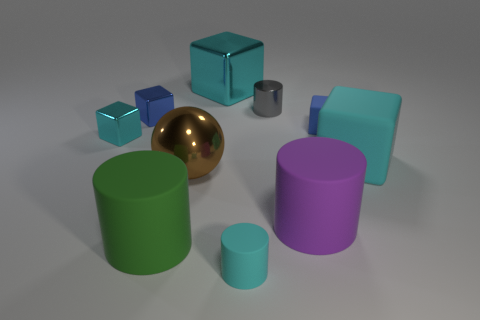Subtract all yellow cylinders. How many cyan cubes are left? 3 Subtract 2 blocks. How many blocks are left? 3 Subtract all big cyan shiny blocks. How many blocks are left? 4 Subtract all purple cubes. Subtract all green cylinders. How many cubes are left? 5 Subtract all cylinders. How many objects are left? 6 Subtract 0 brown cylinders. How many objects are left? 10 Subtract all cubes. Subtract all small blue rubber cubes. How many objects are left? 4 Add 7 big cyan objects. How many big cyan objects are left? 9 Add 10 tiny purple metallic balls. How many tiny purple metallic balls exist? 10 